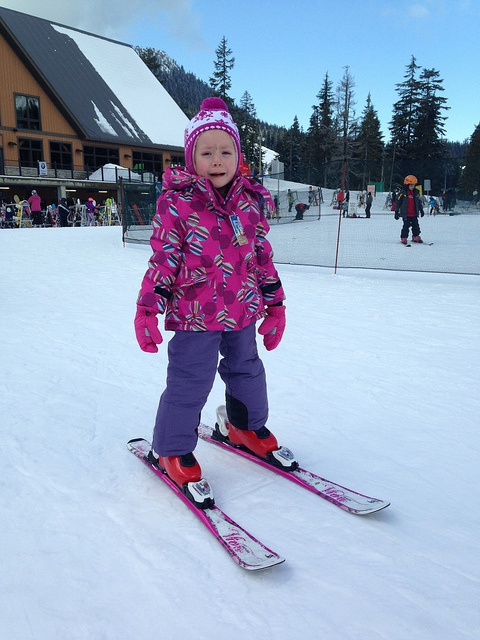Describe the objects in this image and their specific colors. I can see people in lightblue, purple, navy, and black tones, skis in lightblue, darkgray, and black tones, people in lightblue, black, maroon, and gray tones, people in lightblue, black, purple, and gray tones, and people in lightblue, black, purple, gray, and navy tones in this image. 